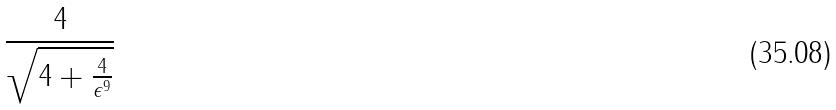Convert formula to latex. <formula><loc_0><loc_0><loc_500><loc_500>\frac { 4 } { \sqrt { 4 + \frac { 4 } { \epsilon ^ { 9 } } } }</formula> 